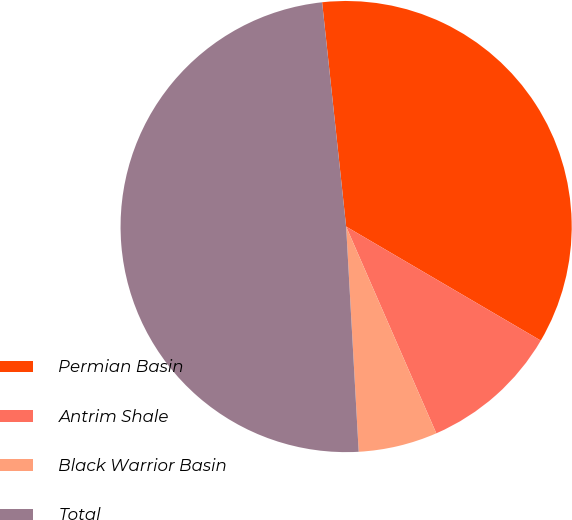Convert chart. <chart><loc_0><loc_0><loc_500><loc_500><pie_chart><fcel>Permian Basin<fcel>Antrim Shale<fcel>Black Warrior Basin<fcel>Total<nl><fcel>35.13%<fcel>10.02%<fcel>5.66%<fcel>49.19%<nl></chart> 